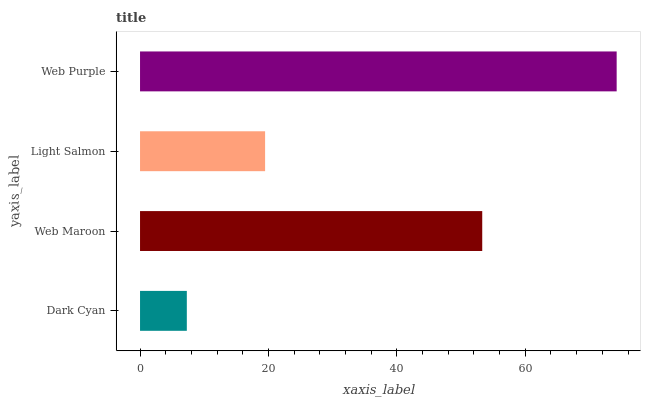Is Dark Cyan the minimum?
Answer yes or no. Yes. Is Web Purple the maximum?
Answer yes or no. Yes. Is Web Maroon the minimum?
Answer yes or no. No. Is Web Maroon the maximum?
Answer yes or no. No. Is Web Maroon greater than Dark Cyan?
Answer yes or no. Yes. Is Dark Cyan less than Web Maroon?
Answer yes or no. Yes. Is Dark Cyan greater than Web Maroon?
Answer yes or no. No. Is Web Maroon less than Dark Cyan?
Answer yes or no. No. Is Web Maroon the high median?
Answer yes or no. Yes. Is Light Salmon the low median?
Answer yes or no. Yes. Is Web Purple the high median?
Answer yes or no. No. Is Web Purple the low median?
Answer yes or no. No. 